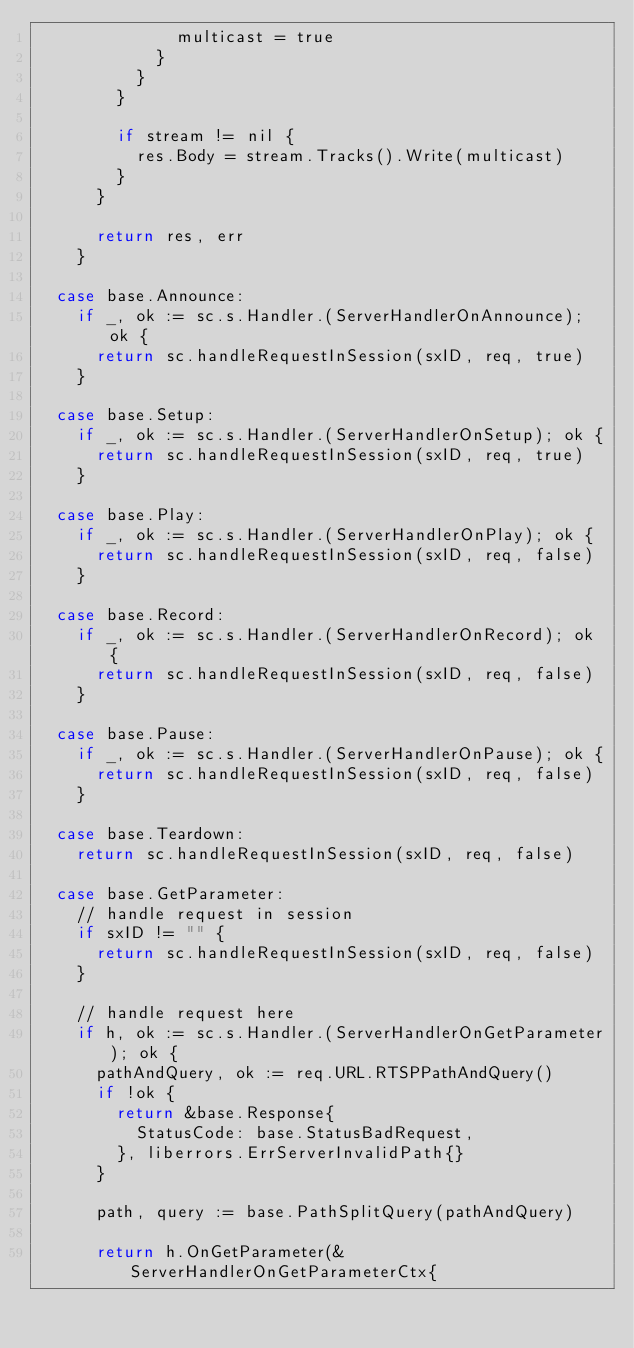Convert code to text. <code><loc_0><loc_0><loc_500><loc_500><_Go_>							multicast = true
						}
					}
				}

				if stream != nil {
					res.Body = stream.Tracks().Write(multicast)
				}
			}

			return res, err
		}

	case base.Announce:
		if _, ok := sc.s.Handler.(ServerHandlerOnAnnounce); ok {
			return sc.handleRequestInSession(sxID, req, true)
		}

	case base.Setup:
		if _, ok := sc.s.Handler.(ServerHandlerOnSetup); ok {
			return sc.handleRequestInSession(sxID, req, true)
		}

	case base.Play:
		if _, ok := sc.s.Handler.(ServerHandlerOnPlay); ok {
			return sc.handleRequestInSession(sxID, req, false)
		}

	case base.Record:
		if _, ok := sc.s.Handler.(ServerHandlerOnRecord); ok {
			return sc.handleRequestInSession(sxID, req, false)
		}

	case base.Pause:
		if _, ok := sc.s.Handler.(ServerHandlerOnPause); ok {
			return sc.handleRequestInSession(sxID, req, false)
		}

	case base.Teardown:
		return sc.handleRequestInSession(sxID, req, false)

	case base.GetParameter:
		// handle request in session
		if sxID != "" {
			return sc.handleRequestInSession(sxID, req, false)
		}

		// handle request here
		if h, ok := sc.s.Handler.(ServerHandlerOnGetParameter); ok {
			pathAndQuery, ok := req.URL.RTSPPathAndQuery()
			if !ok {
				return &base.Response{
					StatusCode: base.StatusBadRequest,
				}, liberrors.ErrServerInvalidPath{}
			}

			path, query := base.PathSplitQuery(pathAndQuery)

			return h.OnGetParameter(&ServerHandlerOnGetParameterCtx{</code> 